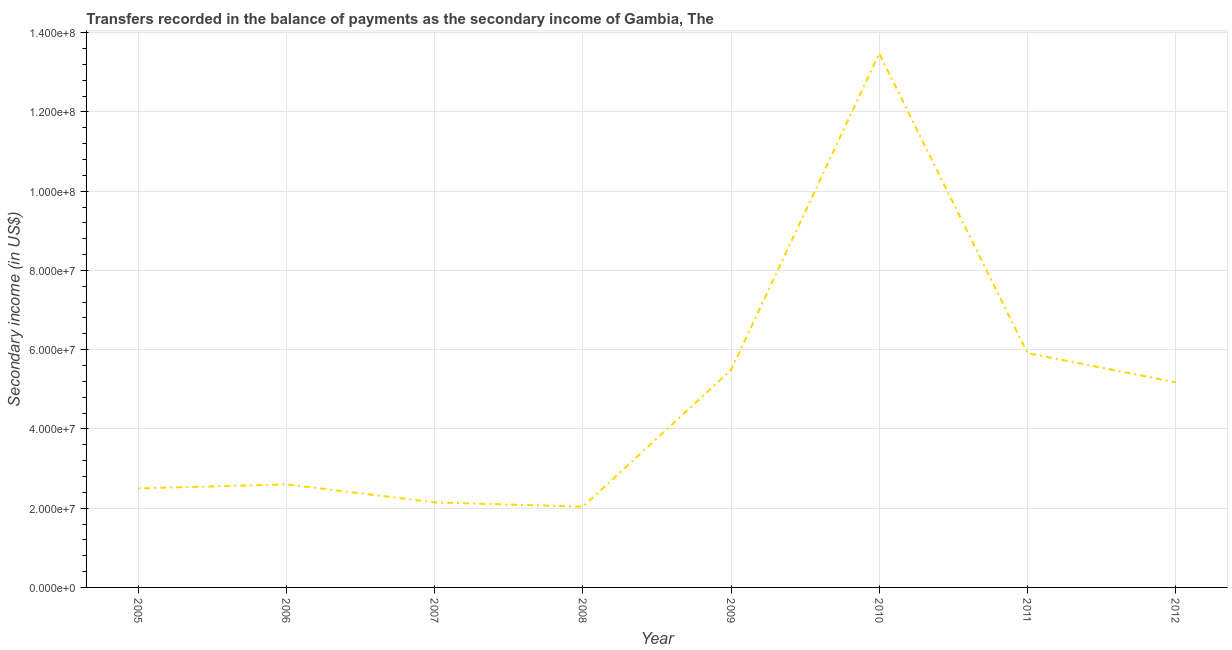What is the amount of secondary income in 2011?
Your answer should be very brief. 5.91e+07. Across all years, what is the maximum amount of secondary income?
Keep it short and to the point. 1.35e+08. Across all years, what is the minimum amount of secondary income?
Offer a very short reply. 2.04e+07. In which year was the amount of secondary income minimum?
Your response must be concise. 2008. What is the sum of the amount of secondary income?
Your answer should be compact. 3.93e+08. What is the difference between the amount of secondary income in 2006 and 2011?
Your response must be concise. -3.31e+07. What is the average amount of secondary income per year?
Provide a short and direct response. 4.92e+07. What is the median amount of secondary income?
Ensure brevity in your answer.  3.89e+07. In how many years, is the amount of secondary income greater than 4000000 US$?
Offer a terse response. 8. What is the ratio of the amount of secondary income in 2005 to that in 2012?
Provide a short and direct response. 0.48. Is the amount of secondary income in 2006 less than that in 2008?
Your answer should be compact. No. What is the difference between the highest and the second highest amount of secondary income?
Your answer should be very brief. 7.56e+07. What is the difference between the highest and the lowest amount of secondary income?
Your answer should be very brief. 1.14e+08. In how many years, is the amount of secondary income greater than the average amount of secondary income taken over all years?
Offer a very short reply. 4. Does the amount of secondary income monotonically increase over the years?
Provide a succinct answer. No. How many years are there in the graph?
Your answer should be very brief. 8. What is the difference between two consecutive major ticks on the Y-axis?
Offer a terse response. 2.00e+07. Are the values on the major ticks of Y-axis written in scientific E-notation?
Ensure brevity in your answer.  Yes. What is the title of the graph?
Provide a short and direct response. Transfers recorded in the balance of payments as the secondary income of Gambia, The. What is the label or title of the Y-axis?
Your answer should be very brief. Secondary income (in US$). What is the Secondary income (in US$) of 2005?
Keep it short and to the point. 2.50e+07. What is the Secondary income (in US$) in 2006?
Offer a very short reply. 2.60e+07. What is the Secondary income (in US$) of 2007?
Your answer should be compact. 2.15e+07. What is the Secondary income (in US$) of 2008?
Give a very brief answer. 2.04e+07. What is the Secondary income (in US$) in 2009?
Your answer should be compact. 5.49e+07. What is the Secondary income (in US$) in 2010?
Provide a succinct answer. 1.35e+08. What is the Secondary income (in US$) in 2011?
Your response must be concise. 5.91e+07. What is the Secondary income (in US$) of 2012?
Offer a terse response. 5.18e+07. What is the difference between the Secondary income (in US$) in 2005 and 2006?
Make the answer very short. -1.01e+06. What is the difference between the Secondary income (in US$) in 2005 and 2007?
Provide a succinct answer. 3.53e+06. What is the difference between the Secondary income (in US$) in 2005 and 2008?
Your answer should be compact. 4.63e+06. What is the difference between the Secondary income (in US$) in 2005 and 2009?
Give a very brief answer. -2.99e+07. What is the difference between the Secondary income (in US$) in 2005 and 2010?
Your response must be concise. -1.10e+08. What is the difference between the Secondary income (in US$) in 2005 and 2011?
Make the answer very short. -3.41e+07. What is the difference between the Secondary income (in US$) in 2005 and 2012?
Make the answer very short. -2.68e+07. What is the difference between the Secondary income (in US$) in 2006 and 2007?
Your answer should be very brief. 4.54e+06. What is the difference between the Secondary income (in US$) in 2006 and 2008?
Your answer should be compact. 5.64e+06. What is the difference between the Secondary income (in US$) in 2006 and 2009?
Your answer should be compact. -2.89e+07. What is the difference between the Secondary income (in US$) in 2006 and 2010?
Ensure brevity in your answer.  -1.09e+08. What is the difference between the Secondary income (in US$) in 2006 and 2011?
Your answer should be compact. -3.31e+07. What is the difference between the Secondary income (in US$) in 2006 and 2012?
Keep it short and to the point. -2.58e+07. What is the difference between the Secondary income (in US$) in 2007 and 2008?
Offer a terse response. 1.10e+06. What is the difference between the Secondary income (in US$) in 2007 and 2009?
Offer a very short reply. -3.34e+07. What is the difference between the Secondary income (in US$) in 2007 and 2010?
Offer a very short reply. -1.13e+08. What is the difference between the Secondary income (in US$) in 2007 and 2011?
Provide a succinct answer. -3.77e+07. What is the difference between the Secondary income (in US$) in 2007 and 2012?
Offer a terse response. -3.03e+07. What is the difference between the Secondary income (in US$) in 2008 and 2009?
Your response must be concise. -3.45e+07. What is the difference between the Secondary income (in US$) in 2008 and 2010?
Your response must be concise. -1.14e+08. What is the difference between the Secondary income (in US$) in 2008 and 2011?
Ensure brevity in your answer.  -3.88e+07. What is the difference between the Secondary income (in US$) in 2008 and 2012?
Offer a very short reply. -3.14e+07. What is the difference between the Secondary income (in US$) in 2009 and 2010?
Give a very brief answer. -7.99e+07. What is the difference between the Secondary income (in US$) in 2009 and 2011?
Give a very brief answer. -4.27e+06. What is the difference between the Secondary income (in US$) in 2009 and 2012?
Keep it short and to the point. 3.09e+06. What is the difference between the Secondary income (in US$) in 2010 and 2011?
Your response must be concise. 7.56e+07. What is the difference between the Secondary income (in US$) in 2010 and 2012?
Your answer should be very brief. 8.30e+07. What is the difference between the Secondary income (in US$) in 2011 and 2012?
Provide a succinct answer. 7.36e+06. What is the ratio of the Secondary income (in US$) in 2005 to that in 2006?
Offer a very short reply. 0.96. What is the ratio of the Secondary income (in US$) in 2005 to that in 2007?
Your answer should be compact. 1.16. What is the ratio of the Secondary income (in US$) in 2005 to that in 2008?
Give a very brief answer. 1.23. What is the ratio of the Secondary income (in US$) in 2005 to that in 2009?
Your answer should be very brief. 0.46. What is the ratio of the Secondary income (in US$) in 2005 to that in 2010?
Your answer should be very brief. 0.19. What is the ratio of the Secondary income (in US$) in 2005 to that in 2011?
Your answer should be very brief. 0.42. What is the ratio of the Secondary income (in US$) in 2005 to that in 2012?
Provide a succinct answer. 0.48. What is the ratio of the Secondary income (in US$) in 2006 to that in 2007?
Your response must be concise. 1.21. What is the ratio of the Secondary income (in US$) in 2006 to that in 2008?
Keep it short and to the point. 1.28. What is the ratio of the Secondary income (in US$) in 2006 to that in 2009?
Offer a terse response. 0.47. What is the ratio of the Secondary income (in US$) in 2006 to that in 2010?
Offer a terse response. 0.19. What is the ratio of the Secondary income (in US$) in 2006 to that in 2011?
Your response must be concise. 0.44. What is the ratio of the Secondary income (in US$) in 2006 to that in 2012?
Offer a very short reply. 0.5. What is the ratio of the Secondary income (in US$) in 2007 to that in 2008?
Your response must be concise. 1.05. What is the ratio of the Secondary income (in US$) in 2007 to that in 2009?
Provide a short and direct response. 0.39. What is the ratio of the Secondary income (in US$) in 2007 to that in 2010?
Provide a succinct answer. 0.16. What is the ratio of the Secondary income (in US$) in 2007 to that in 2011?
Keep it short and to the point. 0.36. What is the ratio of the Secondary income (in US$) in 2007 to that in 2012?
Give a very brief answer. 0.41. What is the ratio of the Secondary income (in US$) in 2008 to that in 2009?
Your answer should be very brief. 0.37. What is the ratio of the Secondary income (in US$) in 2008 to that in 2010?
Offer a very short reply. 0.15. What is the ratio of the Secondary income (in US$) in 2008 to that in 2011?
Your response must be concise. 0.34. What is the ratio of the Secondary income (in US$) in 2008 to that in 2012?
Offer a terse response. 0.39. What is the ratio of the Secondary income (in US$) in 2009 to that in 2010?
Offer a terse response. 0.41. What is the ratio of the Secondary income (in US$) in 2009 to that in 2011?
Keep it short and to the point. 0.93. What is the ratio of the Secondary income (in US$) in 2009 to that in 2012?
Your response must be concise. 1.06. What is the ratio of the Secondary income (in US$) in 2010 to that in 2011?
Your answer should be compact. 2.28. What is the ratio of the Secondary income (in US$) in 2010 to that in 2012?
Ensure brevity in your answer.  2.6. What is the ratio of the Secondary income (in US$) in 2011 to that in 2012?
Provide a succinct answer. 1.14. 